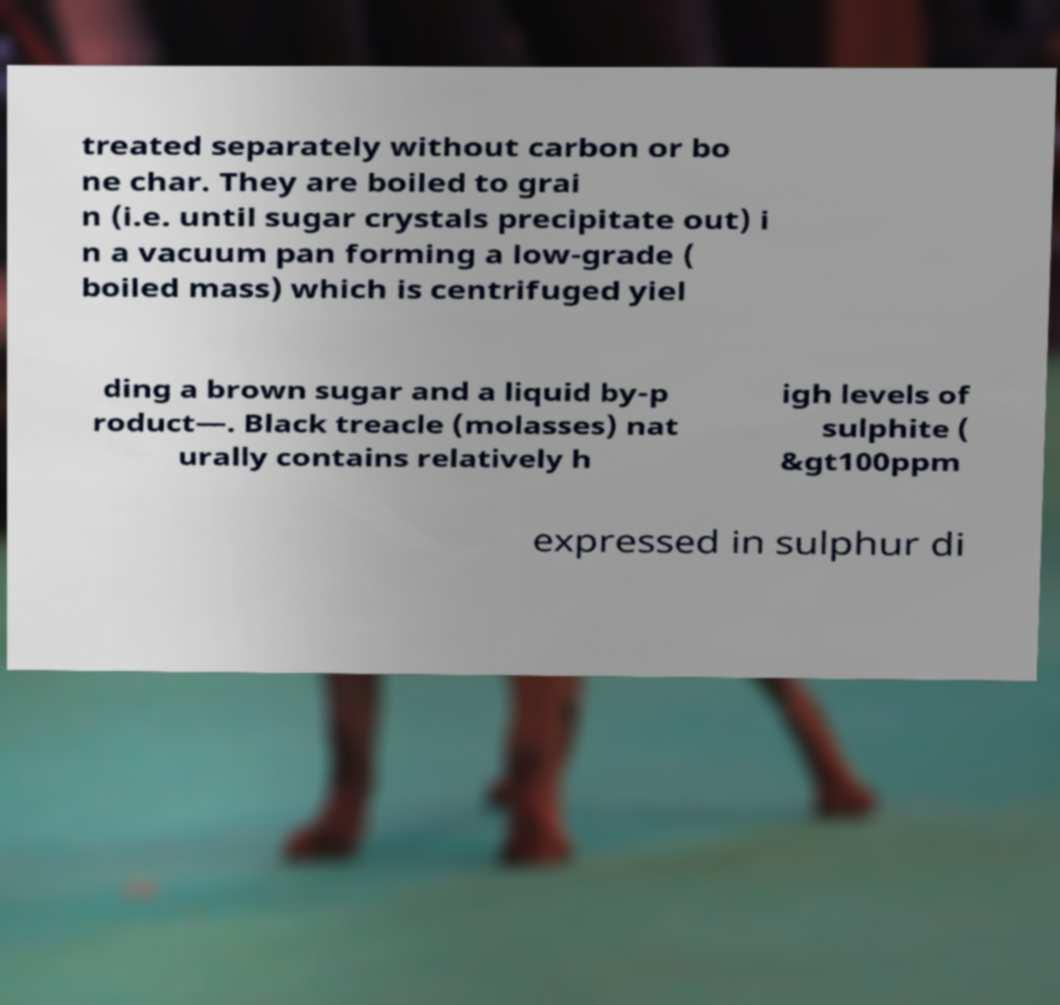Can you accurately transcribe the text from the provided image for me? treated separately without carbon or bo ne char. They are boiled to grai n (i.e. until sugar crystals precipitate out) i n a vacuum pan forming a low-grade ( boiled mass) which is centrifuged yiel ding a brown sugar and a liquid by-p roduct—. Black treacle (molasses) nat urally contains relatively h igh levels of sulphite ( &gt100ppm expressed in sulphur di 